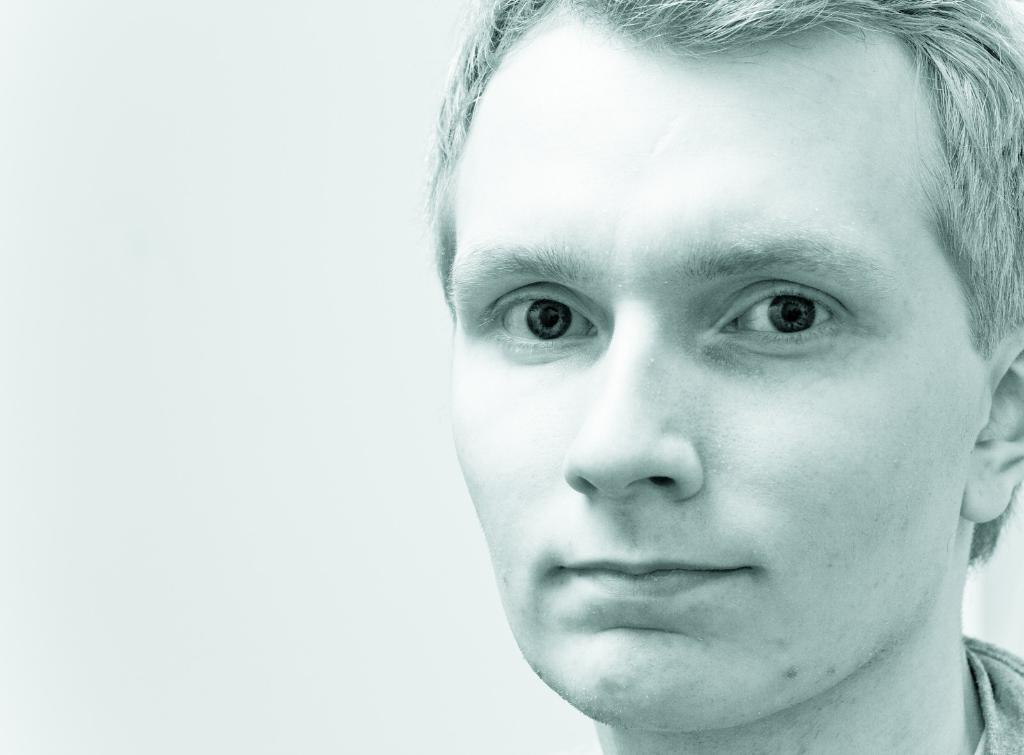What is the main subject of the image? There is a person in the image. What color is the background of the image? The background of the image is white. How many cent coins are on the floor next to the person in the image? There is no mention of cent coins or any other objects on the floor in the image. 